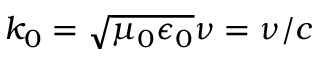Convert formula to latex. <formula><loc_0><loc_0><loc_500><loc_500>k _ { 0 } = \sqrt { \mu _ { 0 } \epsilon _ { 0 } } \nu = \nu / c</formula> 